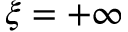<formula> <loc_0><loc_0><loc_500><loc_500>\xi = + \infty</formula> 